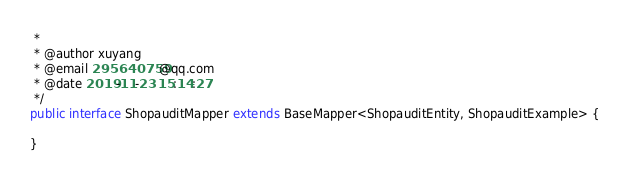Convert code to text. <code><loc_0><loc_0><loc_500><loc_500><_Java_> *
 * @author xuyang
 * @email 295640759@qq.com
 * @date 2019-11-23 15:14:27
 */
public interface ShopauditMapper extends BaseMapper<ShopauditEntity, ShopauditExample> {

}
</code> 